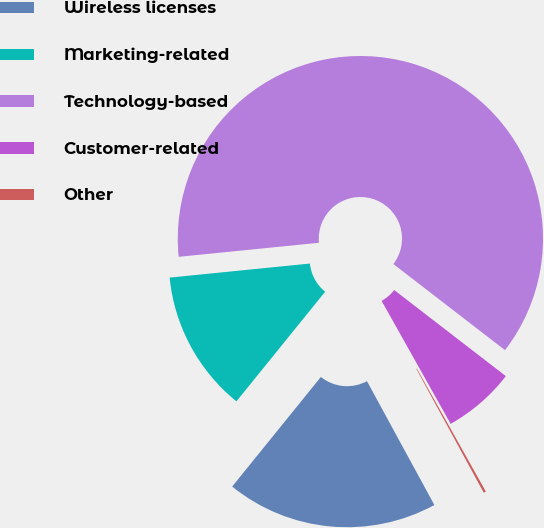Convert chart. <chart><loc_0><loc_0><loc_500><loc_500><pie_chart><fcel>Wireless licenses<fcel>Marketing-related<fcel>Technology-based<fcel>Customer-related<fcel>Other<nl><fcel>18.76%<fcel>12.58%<fcel>62.04%<fcel>6.4%<fcel>0.21%<nl></chart> 